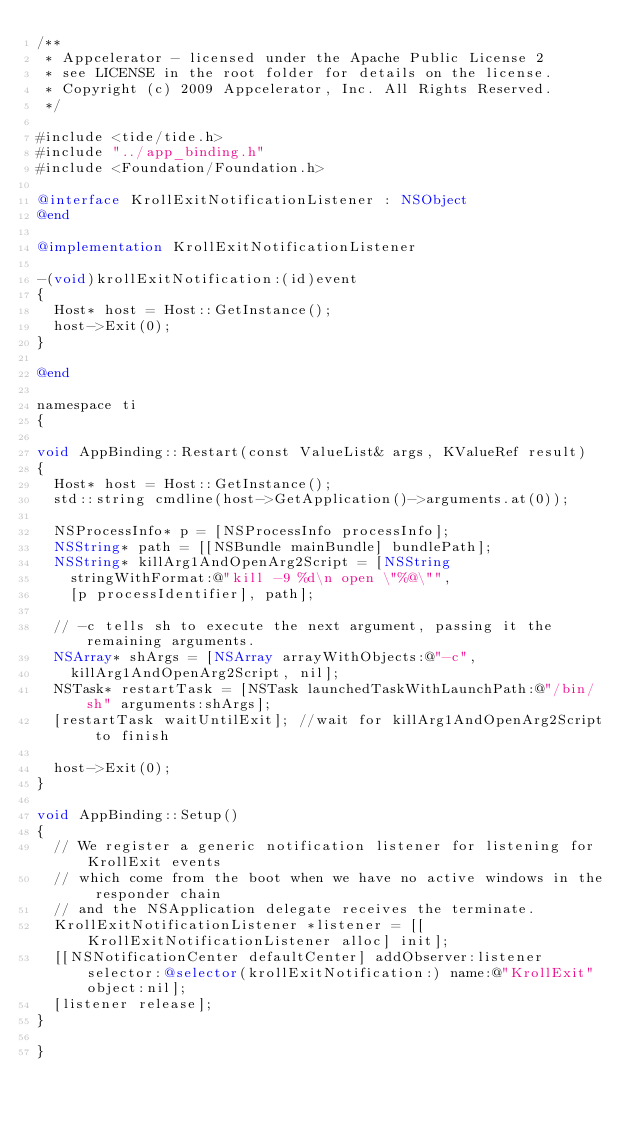<code> <loc_0><loc_0><loc_500><loc_500><_ObjectiveC_>/**
 * Appcelerator - licensed under the Apache Public License 2
 * see LICENSE in the root folder for details on the license.
 * Copyright (c) 2009 Appcelerator, Inc. All Rights Reserved.
 */

#include <tide/tide.h>
#include "../app_binding.h"
#include <Foundation/Foundation.h>

@interface KrollExitNotificationListener : NSObject
@end

@implementation KrollExitNotificationListener

-(void)krollExitNotification:(id)event
{
	Host* host = Host::GetInstance();
	host->Exit(0);
}

@end

namespace ti
{

void AppBinding::Restart(const ValueList& args, KValueRef result)
{
	Host* host = Host::GetInstance();
	std::string cmdline(host->GetApplication()->arguments.at(0));

	NSProcessInfo* p = [NSProcessInfo processInfo];
	NSString* path = [[NSBundle mainBundle] bundlePath];
	NSString* killArg1AndOpenArg2Script = [NSString 
		stringWithFormat:@"kill -9 %d\n open \"%@\"",
		[p processIdentifier], path];

	// -c tells sh to execute the next argument, passing it the remaining arguments.
	NSArray* shArgs = [NSArray arrayWithObjects:@"-c",
		killArg1AndOpenArg2Script, nil];
	NSTask* restartTask = [NSTask launchedTaskWithLaunchPath:@"/bin/sh" arguments:shArgs];
	[restartTask waitUntilExit]; //wait for killArg1AndOpenArg2Script to finish

	host->Exit(0);
}

void AppBinding::Setup() 
{
	// We register a generic notification listener for listening for KrollExit events
	// which come from the boot when we have no active windows in the responder chain
	// and the NSApplication delegate receives the terminate.  
	KrollExitNotificationListener *listener = [[KrollExitNotificationListener alloc] init];
	[[NSNotificationCenter defaultCenter] addObserver:listener selector:@selector(krollExitNotification:) name:@"KrollExit" object:nil];
	[listener release];
}

}
</code> 